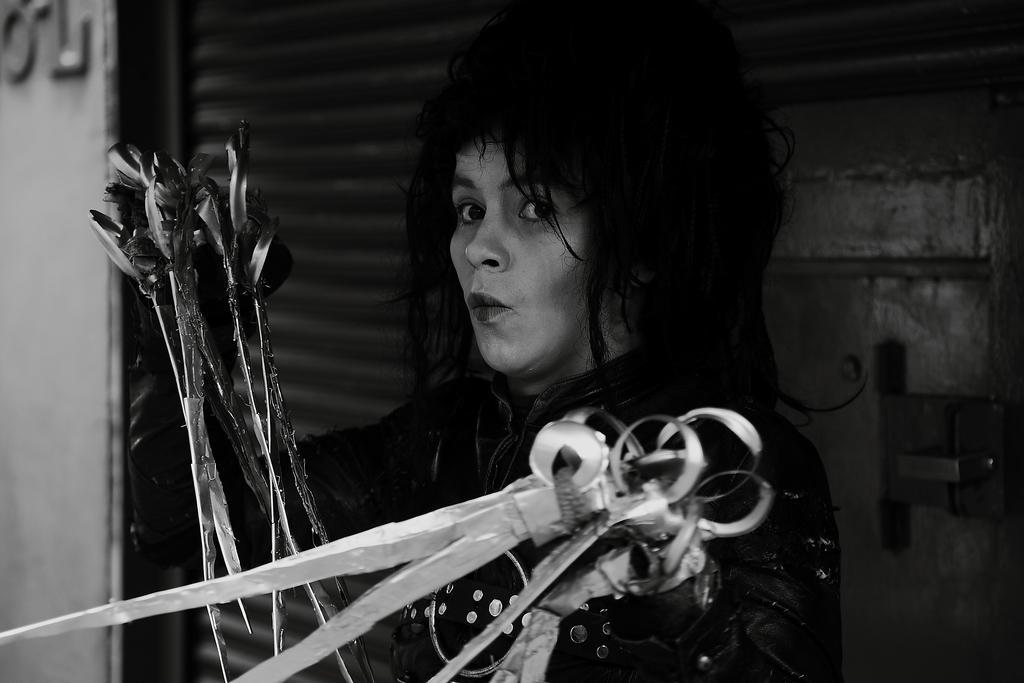Can you describe this image briefly? In the center of the image we can see a person holding arrows and swords. In the background there is a door and a wall. 